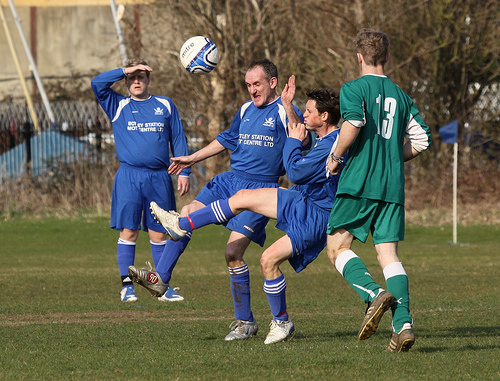<image>
Is the shirt on the man? No. The shirt is not positioned on the man. They may be near each other, but the shirt is not supported by or resting on top of the man. Is the blue player in front of the green player? Yes. The blue player is positioned in front of the green player, appearing closer to the camera viewpoint. Where is the soccer ball in relation to the soccer player? Is it above the soccer player? Yes. The soccer ball is positioned above the soccer player in the vertical space, higher up in the scene. 